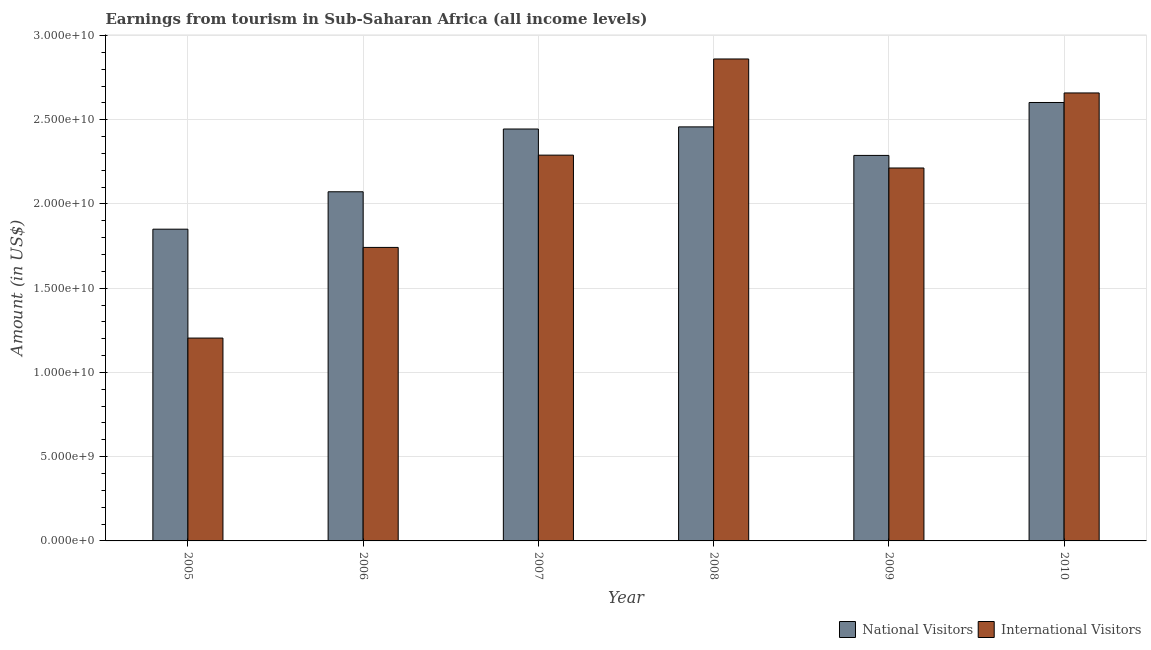How many different coloured bars are there?
Ensure brevity in your answer.  2. What is the label of the 5th group of bars from the left?
Offer a very short reply. 2009. In how many cases, is the number of bars for a given year not equal to the number of legend labels?
Provide a succinct answer. 0. What is the amount earned from national visitors in 2008?
Your answer should be very brief. 2.46e+1. Across all years, what is the maximum amount earned from national visitors?
Provide a succinct answer. 2.60e+1. Across all years, what is the minimum amount earned from international visitors?
Offer a very short reply. 1.20e+1. In which year was the amount earned from national visitors minimum?
Provide a succinct answer. 2005. What is the total amount earned from international visitors in the graph?
Your response must be concise. 1.30e+11. What is the difference between the amount earned from international visitors in 2007 and that in 2009?
Provide a succinct answer. 7.64e+08. What is the difference between the amount earned from national visitors in 2006 and the amount earned from international visitors in 2009?
Give a very brief answer. -2.16e+09. What is the average amount earned from national visitors per year?
Provide a short and direct response. 2.29e+1. In how many years, is the amount earned from national visitors greater than 4000000000 US$?
Offer a very short reply. 6. What is the ratio of the amount earned from national visitors in 2007 to that in 2010?
Your response must be concise. 0.94. Is the difference between the amount earned from international visitors in 2007 and 2009 greater than the difference between the amount earned from national visitors in 2007 and 2009?
Keep it short and to the point. No. What is the difference between the highest and the second highest amount earned from national visitors?
Offer a terse response. 1.45e+09. What is the difference between the highest and the lowest amount earned from national visitors?
Provide a short and direct response. 7.52e+09. In how many years, is the amount earned from international visitors greater than the average amount earned from international visitors taken over all years?
Provide a short and direct response. 4. Is the sum of the amount earned from national visitors in 2005 and 2010 greater than the maximum amount earned from international visitors across all years?
Ensure brevity in your answer.  Yes. What does the 1st bar from the left in 2006 represents?
Your answer should be very brief. National Visitors. What does the 2nd bar from the right in 2010 represents?
Give a very brief answer. National Visitors. How many bars are there?
Offer a very short reply. 12. How many years are there in the graph?
Offer a very short reply. 6. What is the difference between two consecutive major ticks on the Y-axis?
Offer a terse response. 5.00e+09. Where does the legend appear in the graph?
Ensure brevity in your answer.  Bottom right. What is the title of the graph?
Your response must be concise. Earnings from tourism in Sub-Saharan Africa (all income levels). What is the Amount (in US$) of National Visitors in 2005?
Make the answer very short. 1.85e+1. What is the Amount (in US$) in International Visitors in 2005?
Give a very brief answer. 1.20e+1. What is the Amount (in US$) of National Visitors in 2006?
Your answer should be very brief. 2.07e+1. What is the Amount (in US$) of International Visitors in 2006?
Give a very brief answer. 1.74e+1. What is the Amount (in US$) of National Visitors in 2007?
Offer a terse response. 2.45e+1. What is the Amount (in US$) of International Visitors in 2007?
Make the answer very short. 2.29e+1. What is the Amount (in US$) of National Visitors in 2008?
Give a very brief answer. 2.46e+1. What is the Amount (in US$) in International Visitors in 2008?
Your response must be concise. 2.86e+1. What is the Amount (in US$) in National Visitors in 2009?
Offer a terse response. 2.29e+1. What is the Amount (in US$) in International Visitors in 2009?
Give a very brief answer. 2.21e+1. What is the Amount (in US$) of National Visitors in 2010?
Offer a very short reply. 2.60e+1. What is the Amount (in US$) in International Visitors in 2010?
Ensure brevity in your answer.  2.66e+1. Across all years, what is the maximum Amount (in US$) in National Visitors?
Keep it short and to the point. 2.60e+1. Across all years, what is the maximum Amount (in US$) in International Visitors?
Provide a succinct answer. 2.86e+1. Across all years, what is the minimum Amount (in US$) of National Visitors?
Provide a succinct answer. 1.85e+1. Across all years, what is the minimum Amount (in US$) in International Visitors?
Offer a very short reply. 1.20e+1. What is the total Amount (in US$) in National Visitors in the graph?
Offer a terse response. 1.37e+11. What is the total Amount (in US$) of International Visitors in the graph?
Provide a succinct answer. 1.30e+11. What is the difference between the Amount (in US$) of National Visitors in 2005 and that in 2006?
Provide a short and direct response. -2.22e+09. What is the difference between the Amount (in US$) of International Visitors in 2005 and that in 2006?
Your answer should be compact. -5.38e+09. What is the difference between the Amount (in US$) in National Visitors in 2005 and that in 2007?
Make the answer very short. -5.95e+09. What is the difference between the Amount (in US$) of International Visitors in 2005 and that in 2007?
Provide a short and direct response. -1.09e+1. What is the difference between the Amount (in US$) of National Visitors in 2005 and that in 2008?
Make the answer very short. -6.07e+09. What is the difference between the Amount (in US$) in International Visitors in 2005 and that in 2008?
Provide a short and direct response. -1.66e+1. What is the difference between the Amount (in US$) of National Visitors in 2005 and that in 2009?
Keep it short and to the point. -4.38e+09. What is the difference between the Amount (in US$) of International Visitors in 2005 and that in 2009?
Your answer should be compact. -1.01e+1. What is the difference between the Amount (in US$) of National Visitors in 2005 and that in 2010?
Offer a very short reply. -7.52e+09. What is the difference between the Amount (in US$) in International Visitors in 2005 and that in 2010?
Your answer should be compact. -1.46e+1. What is the difference between the Amount (in US$) of National Visitors in 2006 and that in 2007?
Your response must be concise. -3.73e+09. What is the difference between the Amount (in US$) of International Visitors in 2006 and that in 2007?
Your response must be concise. -5.48e+09. What is the difference between the Amount (in US$) in National Visitors in 2006 and that in 2008?
Provide a short and direct response. -3.85e+09. What is the difference between the Amount (in US$) in International Visitors in 2006 and that in 2008?
Make the answer very short. -1.12e+1. What is the difference between the Amount (in US$) of National Visitors in 2006 and that in 2009?
Provide a succinct answer. -2.16e+09. What is the difference between the Amount (in US$) in International Visitors in 2006 and that in 2009?
Offer a terse response. -4.71e+09. What is the difference between the Amount (in US$) of National Visitors in 2006 and that in 2010?
Provide a succinct answer. -5.30e+09. What is the difference between the Amount (in US$) in International Visitors in 2006 and that in 2010?
Keep it short and to the point. -9.17e+09. What is the difference between the Amount (in US$) in National Visitors in 2007 and that in 2008?
Provide a short and direct response. -1.26e+08. What is the difference between the Amount (in US$) of International Visitors in 2007 and that in 2008?
Provide a short and direct response. -5.71e+09. What is the difference between the Amount (in US$) in National Visitors in 2007 and that in 2009?
Offer a very short reply. 1.57e+09. What is the difference between the Amount (in US$) of International Visitors in 2007 and that in 2009?
Offer a very short reply. 7.64e+08. What is the difference between the Amount (in US$) in National Visitors in 2007 and that in 2010?
Make the answer very short. -1.57e+09. What is the difference between the Amount (in US$) of International Visitors in 2007 and that in 2010?
Keep it short and to the point. -3.69e+09. What is the difference between the Amount (in US$) in National Visitors in 2008 and that in 2009?
Keep it short and to the point. 1.69e+09. What is the difference between the Amount (in US$) in International Visitors in 2008 and that in 2009?
Your response must be concise. 6.47e+09. What is the difference between the Amount (in US$) in National Visitors in 2008 and that in 2010?
Give a very brief answer. -1.45e+09. What is the difference between the Amount (in US$) in International Visitors in 2008 and that in 2010?
Give a very brief answer. 2.02e+09. What is the difference between the Amount (in US$) of National Visitors in 2009 and that in 2010?
Your response must be concise. -3.14e+09. What is the difference between the Amount (in US$) of International Visitors in 2009 and that in 2010?
Give a very brief answer. -4.45e+09. What is the difference between the Amount (in US$) of National Visitors in 2005 and the Amount (in US$) of International Visitors in 2006?
Make the answer very short. 1.08e+09. What is the difference between the Amount (in US$) of National Visitors in 2005 and the Amount (in US$) of International Visitors in 2007?
Make the answer very short. -4.40e+09. What is the difference between the Amount (in US$) of National Visitors in 2005 and the Amount (in US$) of International Visitors in 2008?
Provide a succinct answer. -1.01e+1. What is the difference between the Amount (in US$) in National Visitors in 2005 and the Amount (in US$) in International Visitors in 2009?
Offer a terse response. -3.63e+09. What is the difference between the Amount (in US$) in National Visitors in 2005 and the Amount (in US$) in International Visitors in 2010?
Ensure brevity in your answer.  -8.09e+09. What is the difference between the Amount (in US$) in National Visitors in 2006 and the Amount (in US$) in International Visitors in 2007?
Your answer should be compact. -2.18e+09. What is the difference between the Amount (in US$) in National Visitors in 2006 and the Amount (in US$) in International Visitors in 2008?
Your answer should be very brief. -7.88e+09. What is the difference between the Amount (in US$) of National Visitors in 2006 and the Amount (in US$) of International Visitors in 2009?
Your answer should be compact. -1.41e+09. What is the difference between the Amount (in US$) in National Visitors in 2006 and the Amount (in US$) in International Visitors in 2010?
Give a very brief answer. -5.87e+09. What is the difference between the Amount (in US$) in National Visitors in 2007 and the Amount (in US$) in International Visitors in 2008?
Keep it short and to the point. -4.16e+09. What is the difference between the Amount (in US$) in National Visitors in 2007 and the Amount (in US$) in International Visitors in 2009?
Keep it short and to the point. 2.31e+09. What is the difference between the Amount (in US$) in National Visitors in 2007 and the Amount (in US$) in International Visitors in 2010?
Your answer should be very brief. -2.14e+09. What is the difference between the Amount (in US$) in National Visitors in 2008 and the Amount (in US$) in International Visitors in 2009?
Provide a short and direct response. 2.44e+09. What is the difference between the Amount (in US$) in National Visitors in 2008 and the Amount (in US$) in International Visitors in 2010?
Offer a very short reply. -2.01e+09. What is the difference between the Amount (in US$) of National Visitors in 2009 and the Amount (in US$) of International Visitors in 2010?
Make the answer very short. -3.71e+09. What is the average Amount (in US$) of National Visitors per year?
Offer a terse response. 2.29e+1. What is the average Amount (in US$) of International Visitors per year?
Keep it short and to the point. 2.16e+1. In the year 2005, what is the difference between the Amount (in US$) of National Visitors and Amount (in US$) of International Visitors?
Keep it short and to the point. 6.46e+09. In the year 2006, what is the difference between the Amount (in US$) of National Visitors and Amount (in US$) of International Visitors?
Ensure brevity in your answer.  3.30e+09. In the year 2007, what is the difference between the Amount (in US$) in National Visitors and Amount (in US$) in International Visitors?
Your response must be concise. 1.55e+09. In the year 2008, what is the difference between the Amount (in US$) in National Visitors and Amount (in US$) in International Visitors?
Offer a terse response. -4.03e+09. In the year 2009, what is the difference between the Amount (in US$) in National Visitors and Amount (in US$) in International Visitors?
Offer a very short reply. 7.46e+08. In the year 2010, what is the difference between the Amount (in US$) of National Visitors and Amount (in US$) of International Visitors?
Your answer should be very brief. -5.67e+08. What is the ratio of the Amount (in US$) of National Visitors in 2005 to that in 2006?
Offer a terse response. 0.89. What is the ratio of the Amount (in US$) in International Visitors in 2005 to that in 2006?
Keep it short and to the point. 0.69. What is the ratio of the Amount (in US$) in National Visitors in 2005 to that in 2007?
Offer a terse response. 0.76. What is the ratio of the Amount (in US$) in International Visitors in 2005 to that in 2007?
Your answer should be very brief. 0.53. What is the ratio of the Amount (in US$) in National Visitors in 2005 to that in 2008?
Offer a very short reply. 0.75. What is the ratio of the Amount (in US$) of International Visitors in 2005 to that in 2008?
Keep it short and to the point. 0.42. What is the ratio of the Amount (in US$) of National Visitors in 2005 to that in 2009?
Your answer should be very brief. 0.81. What is the ratio of the Amount (in US$) in International Visitors in 2005 to that in 2009?
Your response must be concise. 0.54. What is the ratio of the Amount (in US$) in National Visitors in 2005 to that in 2010?
Provide a short and direct response. 0.71. What is the ratio of the Amount (in US$) in International Visitors in 2005 to that in 2010?
Your response must be concise. 0.45. What is the ratio of the Amount (in US$) in National Visitors in 2006 to that in 2007?
Offer a very short reply. 0.85. What is the ratio of the Amount (in US$) of International Visitors in 2006 to that in 2007?
Provide a succinct answer. 0.76. What is the ratio of the Amount (in US$) of National Visitors in 2006 to that in 2008?
Provide a short and direct response. 0.84. What is the ratio of the Amount (in US$) in International Visitors in 2006 to that in 2008?
Give a very brief answer. 0.61. What is the ratio of the Amount (in US$) of National Visitors in 2006 to that in 2009?
Your response must be concise. 0.91. What is the ratio of the Amount (in US$) in International Visitors in 2006 to that in 2009?
Your response must be concise. 0.79. What is the ratio of the Amount (in US$) in National Visitors in 2006 to that in 2010?
Your response must be concise. 0.8. What is the ratio of the Amount (in US$) of International Visitors in 2006 to that in 2010?
Give a very brief answer. 0.66. What is the ratio of the Amount (in US$) of National Visitors in 2007 to that in 2008?
Give a very brief answer. 0.99. What is the ratio of the Amount (in US$) in International Visitors in 2007 to that in 2008?
Your answer should be very brief. 0.8. What is the ratio of the Amount (in US$) in National Visitors in 2007 to that in 2009?
Your response must be concise. 1.07. What is the ratio of the Amount (in US$) of International Visitors in 2007 to that in 2009?
Ensure brevity in your answer.  1.03. What is the ratio of the Amount (in US$) in National Visitors in 2007 to that in 2010?
Ensure brevity in your answer.  0.94. What is the ratio of the Amount (in US$) in International Visitors in 2007 to that in 2010?
Provide a short and direct response. 0.86. What is the ratio of the Amount (in US$) in National Visitors in 2008 to that in 2009?
Offer a very short reply. 1.07. What is the ratio of the Amount (in US$) of International Visitors in 2008 to that in 2009?
Provide a short and direct response. 1.29. What is the ratio of the Amount (in US$) in International Visitors in 2008 to that in 2010?
Provide a succinct answer. 1.08. What is the ratio of the Amount (in US$) in National Visitors in 2009 to that in 2010?
Your answer should be compact. 0.88. What is the ratio of the Amount (in US$) of International Visitors in 2009 to that in 2010?
Provide a succinct answer. 0.83. What is the difference between the highest and the second highest Amount (in US$) in National Visitors?
Give a very brief answer. 1.45e+09. What is the difference between the highest and the second highest Amount (in US$) of International Visitors?
Give a very brief answer. 2.02e+09. What is the difference between the highest and the lowest Amount (in US$) of National Visitors?
Your answer should be very brief. 7.52e+09. What is the difference between the highest and the lowest Amount (in US$) in International Visitors?
Ensure brevity in your answer.  1.66e+1. 